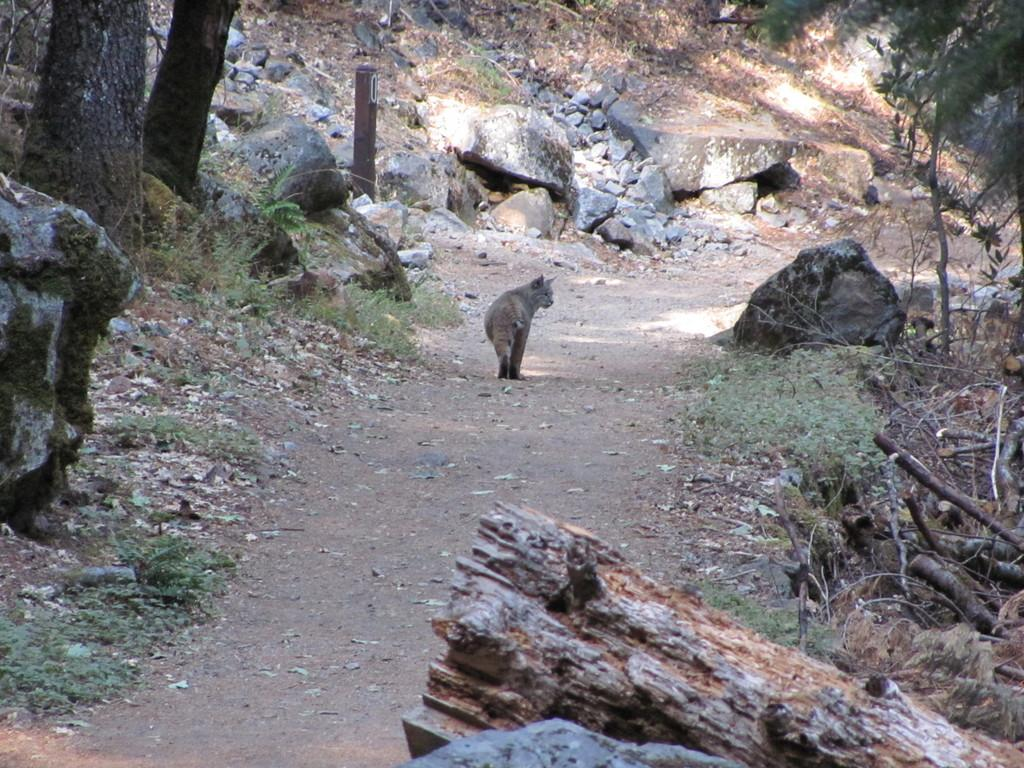What is the main subject of the image? There is an animal walking on the surface in the image. What type of natural features can be seen in the image? Tree trunks, stones, and plants are visible in the image. What type of division is taking place in the image? There is no division present in the image; it features an animal walking on the surface and natural features like tree trunks, stones, and plants. Can you tell me how many buckets are visible in the image? There are no buckets present in the image. 